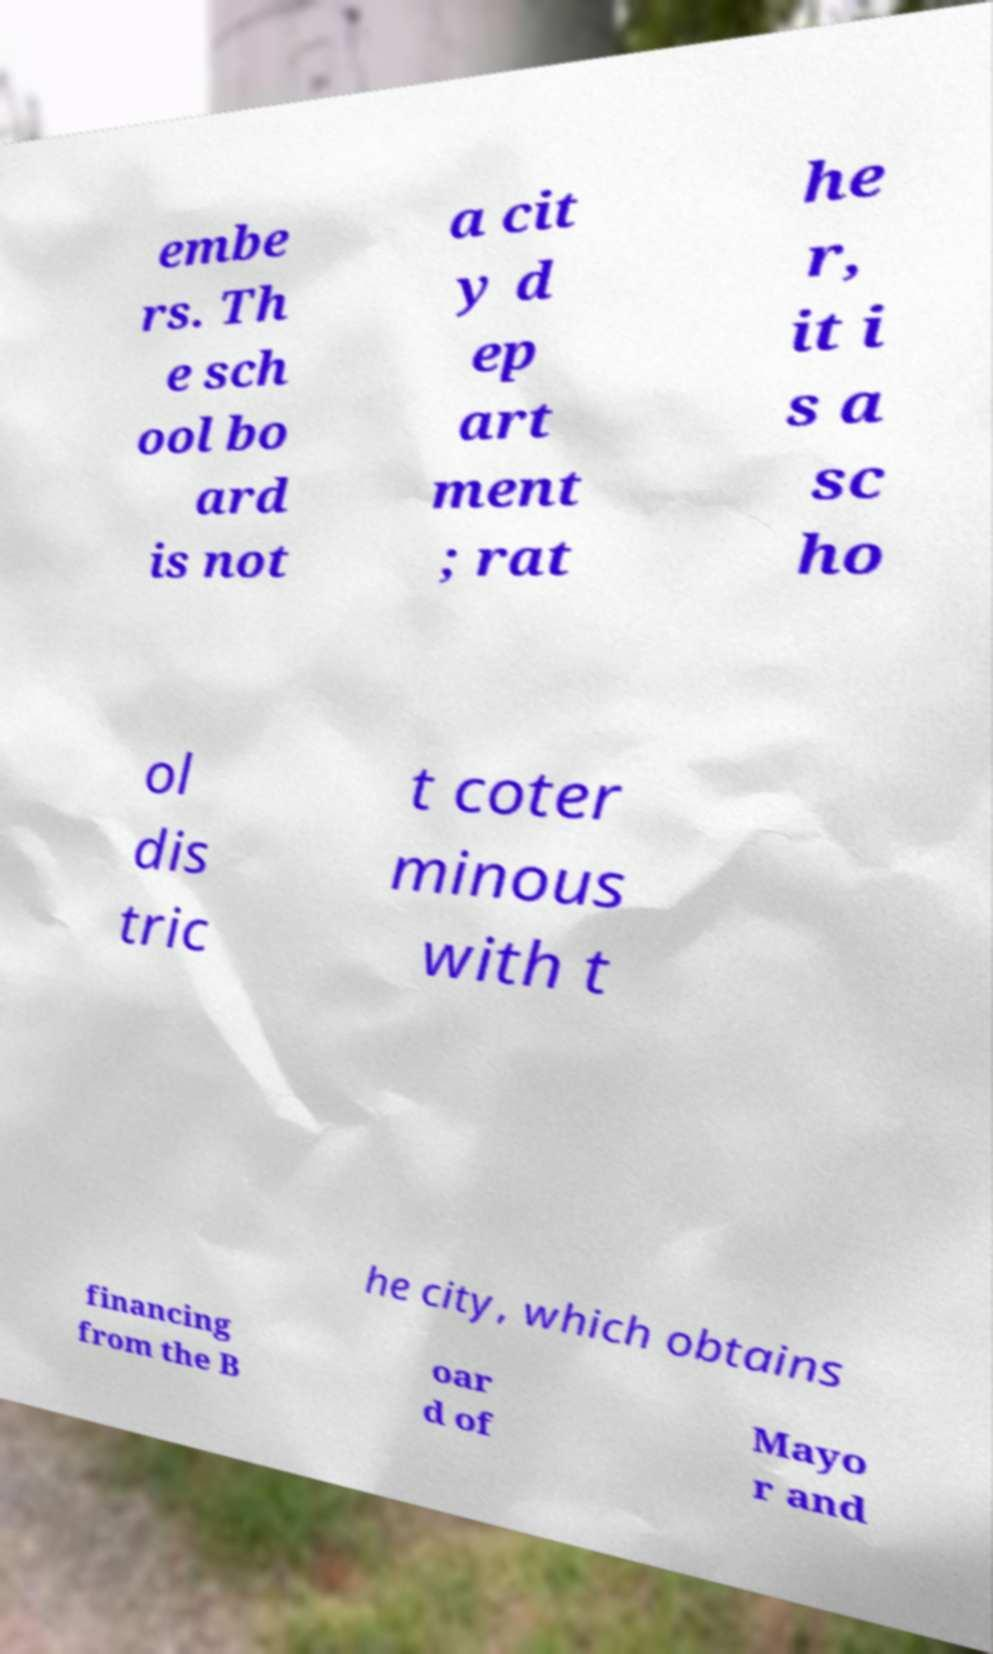For documentation purposes, I need the text within this image transcribed. Could you provide that? embe rs. Th e sch ool bo ard is not a cit y d ep art ment ; rat he r, it i s a sc ho ol dis tric t coter minous with t he city, which obtains financing from the B oar d of Mayo r and 